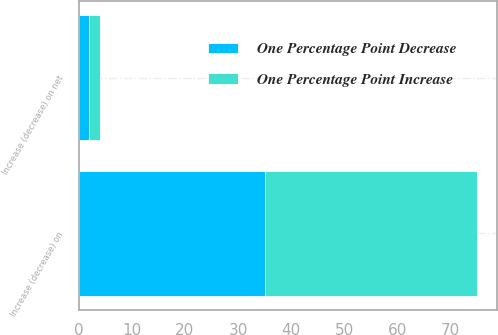Convert chart. <chart><loc_0><loc_0><loc_500><loc_500><stacked_bar_chart><ecel><fcel>Increase (decrease) on<fcel>Increase (decrease) on net<nl><fcel>One Percentage Point Decrease<fcel>35<fcel>2<nl><fcel>One Percentage Point Increase<fcel>40<fcel>2<nl></chart> 